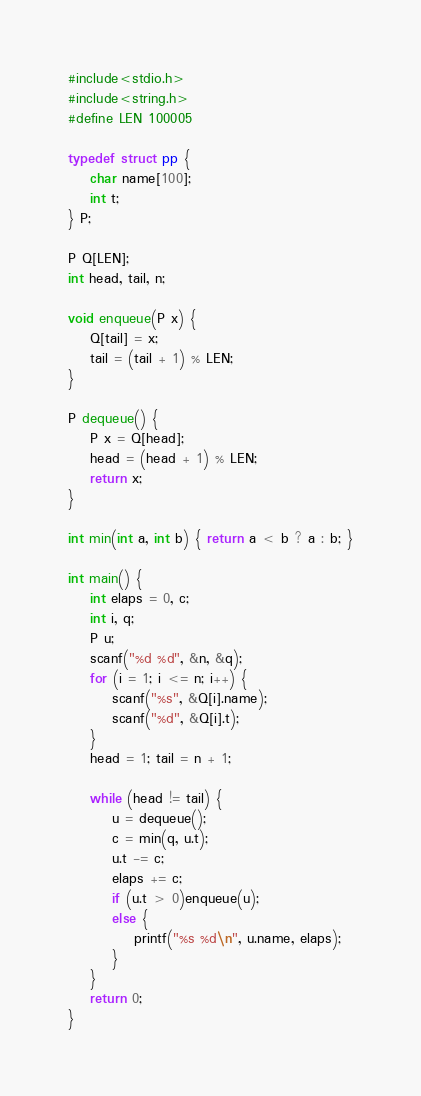Convert code to text. <code><loc_0><loc_0><loc_500><loc_500><_C_>#include<stdio.h>
#include<string.h>
#define LEN 100005

typedef struct pp {
	char name[100];
	int t;
} P;

P Q[LEN];
int head, tail, n;

void enqueue(P x) {
	Q[tail] = x;
	tail = (tail + 1) % LEN;
}

P dequeue() {
	P x = Q[head];
	head = (head + 1) % LEN;
	return x;
}

int min(int a, int b) { return a < b ? a : b; }

int main() {
	int elaps = 0, c;
	int i, q;
	P u;
	scanf("%d %d", &n, &q);
	for (i = 1; i <= n; i++) {
		scanf("%s", &Q[i].name);
		scanf("%d", &Q[i].t);
	}
	head = 1; tail = n + 1;

	while (head != tail) {
		u = dequeue();
		c = min(q, u.t);
		u.t -= c;
		elaps += c;
		if (u.t > 0)enqueue(u);
		else {
			printf("%s %d\n", u.name, elaps);
		}
	}
	return 0;
}</code> 